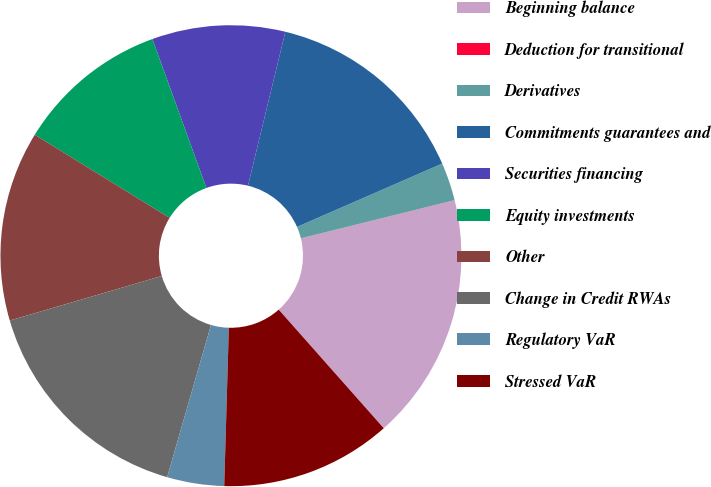Convert chart. <chart><loc_0><loc_0><loc_500><loc_500><pie_chart><fcel>Beginning balance<fcel>Deduction for transitional<fcel>Derivatives<fcel>Commitments guarantees and<fcel>Securities financing<fcel>Equity investments<fcel>Other<fcel>Change in Credit RWAs<fcel>Regulatory VaR<fcel>Stressed VaR<nl><fcel>17.33%<fcel>0.01%<fcel>2.67%<fcel>14.66%<fcel>9.33%<fcel>10.67%<fcel>13.33%<fcel>16.0%<fcel>4.0%<fcel>12.0%<nl></chart> 